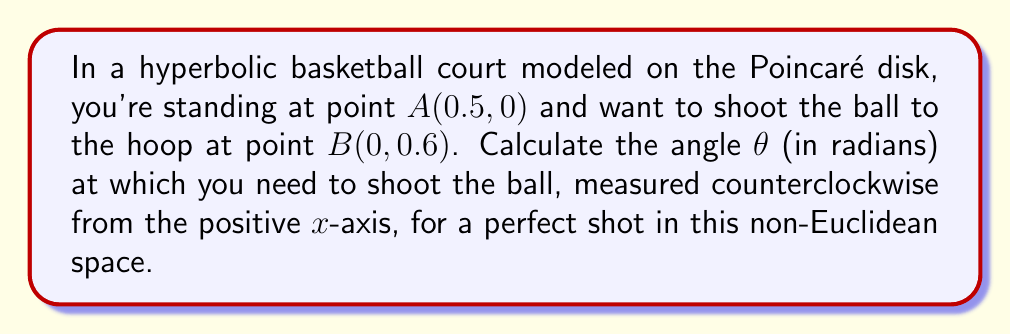Help me with this question. To solve this problem, we'll use the formula for the angle between two points in the Poincaré disk model of hyperbolic geometry:

1) First, recall the formula for the angle θ between two points (x₁, y₁) and (x₂, y₂) in the Poincaré disk:

   $$ \theta = \arg\left(\frac{(x_2-x_1) + i(y_2-y_1)}{1-x_1x_2-y_1y_2+i(x_1y_2-x_2y_1)}\right) $$

2) In our case, A(0.5, 0) and B(0, 0.6), so:
   x₁ = 0.5, y₁ = 0, x₂ = 0, y₂ = 0.6

3) Let's substitute these values into the formula:

   $$ \theta = \arg\left(\frac{(0-0.5) + i(0.6-0)}{1-(0.5)(0)-(0)(0.6)+i((0.5)(0.6)-(0)(0))}\right) $$

4) Simplify:

   $$ \theta = \arg\left(\frac{-0.5 + 0.6i}{1+0.3i}\right) $$

5) To calculate the argument of this complex number, we can use the arctangent function:

   $$ \theta = \arctan\left(\frac{\text{Im}(z)}{\text{Re}(z)}\right) $$

   Where z is our complex fraction.

6) The numerator is -0.5 + 0.6i, and the denominator is 1 + 0.3i.
   Multiply both numerator and denominator by the complex conjugate of the denominator:

   $$ \frac{(-0.5 + 0.6i)(1 - 0.3i)}{(1 + 0.3i)(1 - 0.3i)} = \frac{-0.5 + 0.6i - 0.15i + 0.18}{1 + 0.09} = \frac{-0.32 + 0.45i}{1.09} $$

7) Now we can calculate:

   $$ \theta = \arctan\left(\frac{0.45}{-0.32}\right) $$

8) Calculate this value:

   $$ \theta \approx 2.187 \text{ radians} $$

This is the angle at which you need to shoot the ball in this hyperbolic space for a perfect shot.
Answer: $2.187$ radians 